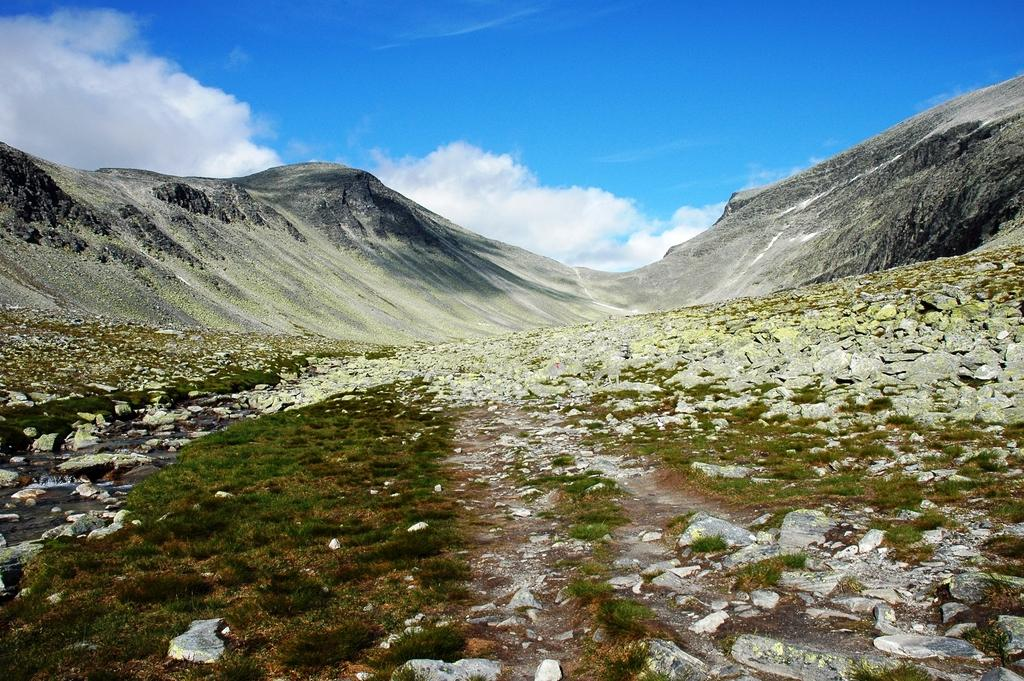What type of terrain is visible in the image? There is grass and rocks in the image. What geographical feature can be seen in the distance? There are mountains in the image. What color is the sky in the background? The sky is blue in the background. Are there any weather phenomena visible in the sky? Yes, there are clouds in the sky. What type of steel is used to construct the respectful way in the image? There is no steel or respectful way present in the image; it features grass, rocks, mountains, and a blue sky with clouds. 